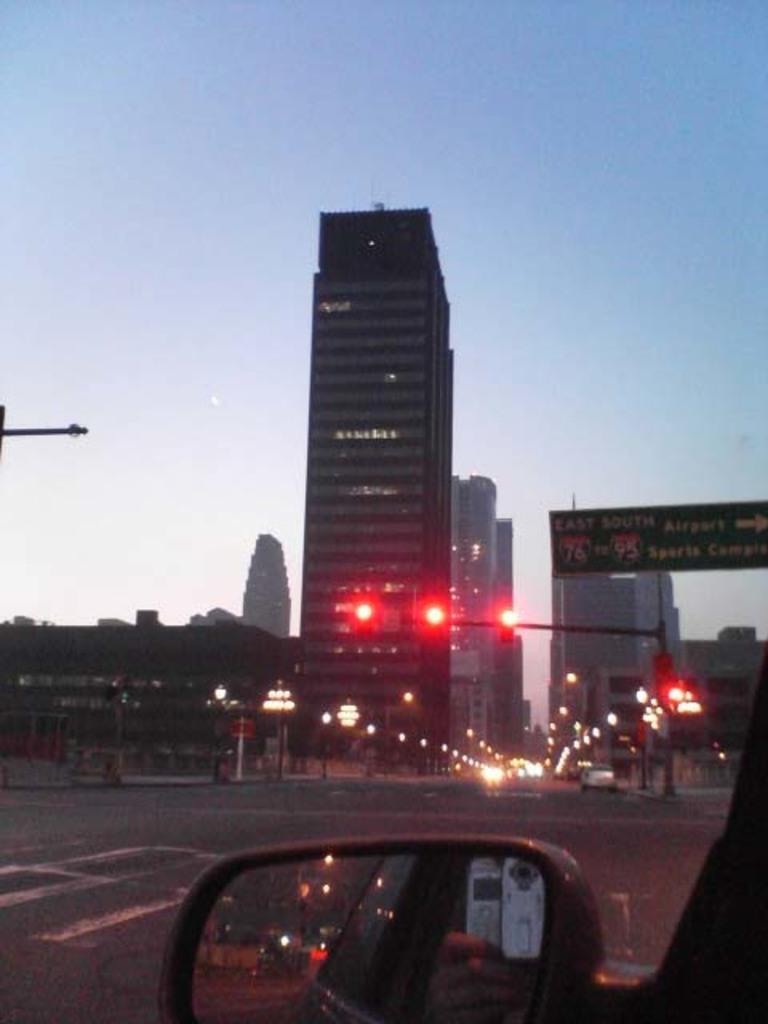What type of buildings can be seen in the image? There are skyscrapers in the image. What else is visible on the ground in the image? There are vehicles on the road in the image. What is the purpose of the object on the side of the road? There is a street light in the image, which is used to illuminate the road. What color are the lights on the street light? The street light's lights are in red color. Can you see any clover growing on the side of the road in the image? There is no clover present in the image. Is there a cave visible in the image? There is no cave present in the image. 